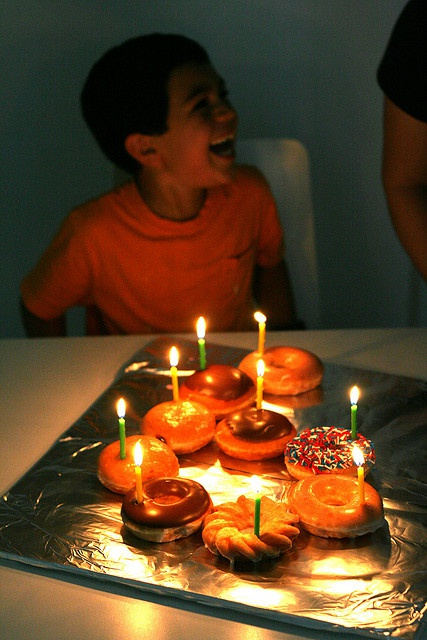Describe the objects in this image and their specific colors. I can see people in black and maroon tones, dining table in black, olive, gray, and orange tones, people in black and maroon tones, chair in black and darkgreen tones, and donut in black, red, orange, and maroon tones in this image. 